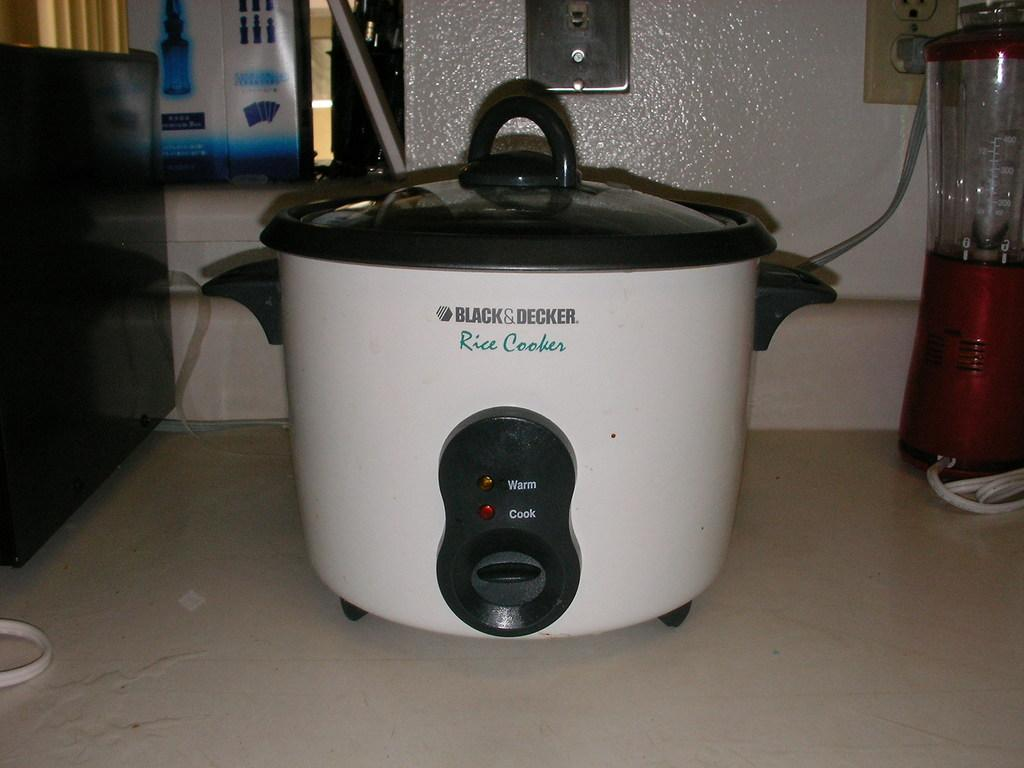<image>
Relay a brief, clear account of the picture shown. White and black rice cooker by Black&Decker on top of a table. 